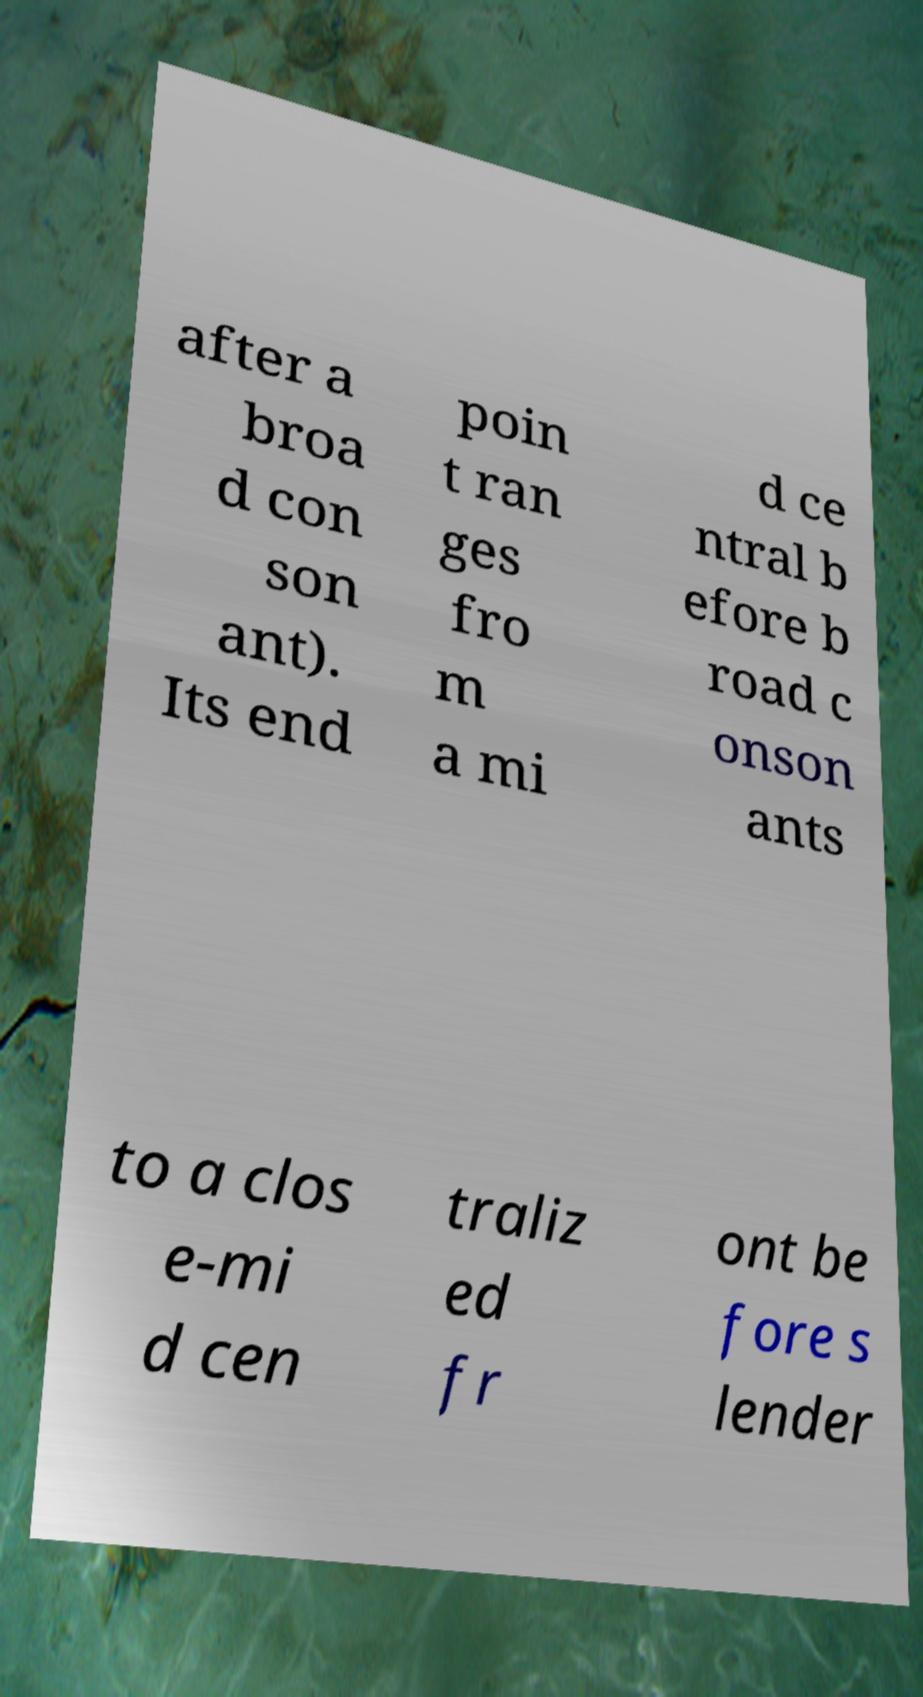Could you extract and type out the text from this image? after a broa d con son ant). Its end poin t ran ges fro m a mi d ce ntral b efore b road c onson ants to a clos e-mi d cen traliz ed fr ont be fore s lender 